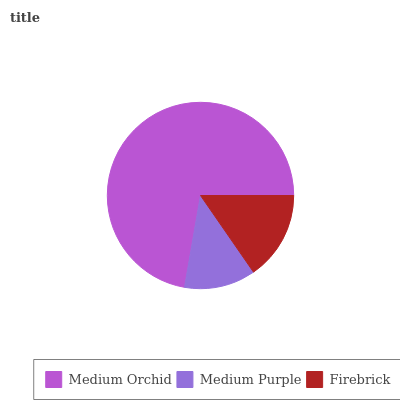Is Medium Purple the minimum?
Answer yes or no. Yes. Is Medium Orchid the maximum?
Answer yes or no. Yes. Is Firebrick the minimum?
Answer yes or no. No. Is Firebrick the maximum?
Answer yes or no. No. Is Firebrick greater than Medium Purple?
Answer yes or no. Yes. Is Medium Purple less than Firebrick?
Answer yes or no. Yes. Is Medium Purple greater than Firebrick?
Answer yes or no. No. Is Firebrick less than Medium Purple?
Answer yes or no. No. Is Firebrick the high median?
Answer yes or no. Yes. Is Firebrick the low median?
Answer yes or no. Yes. Is Medium Purple the high median?
Answer yes or no. No. Is Medium Orchid the low median?
Answer yes or no. No. 